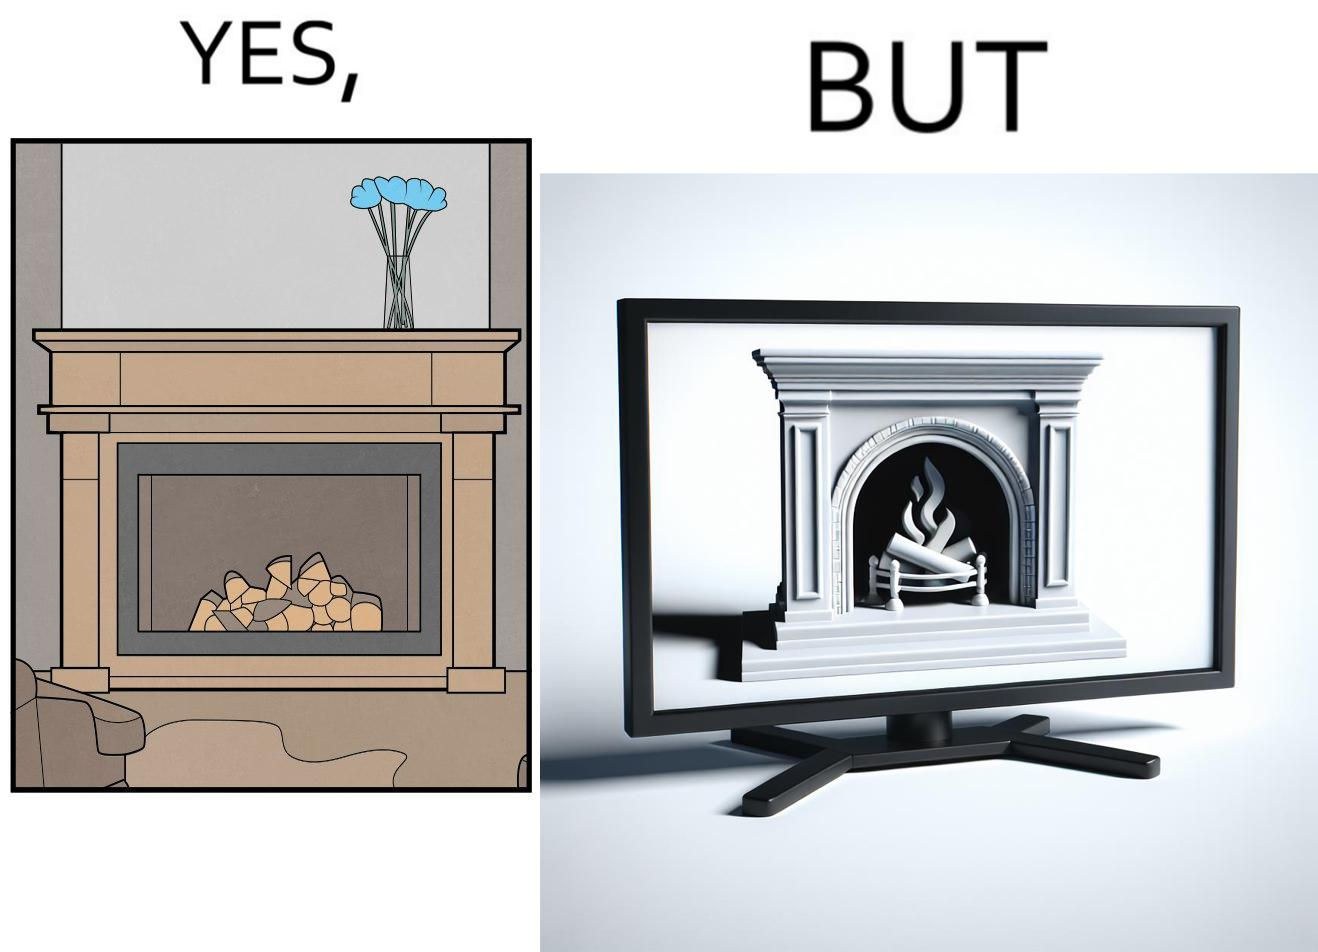Does this image contain satire or humor? Yes, this image is satirical. 